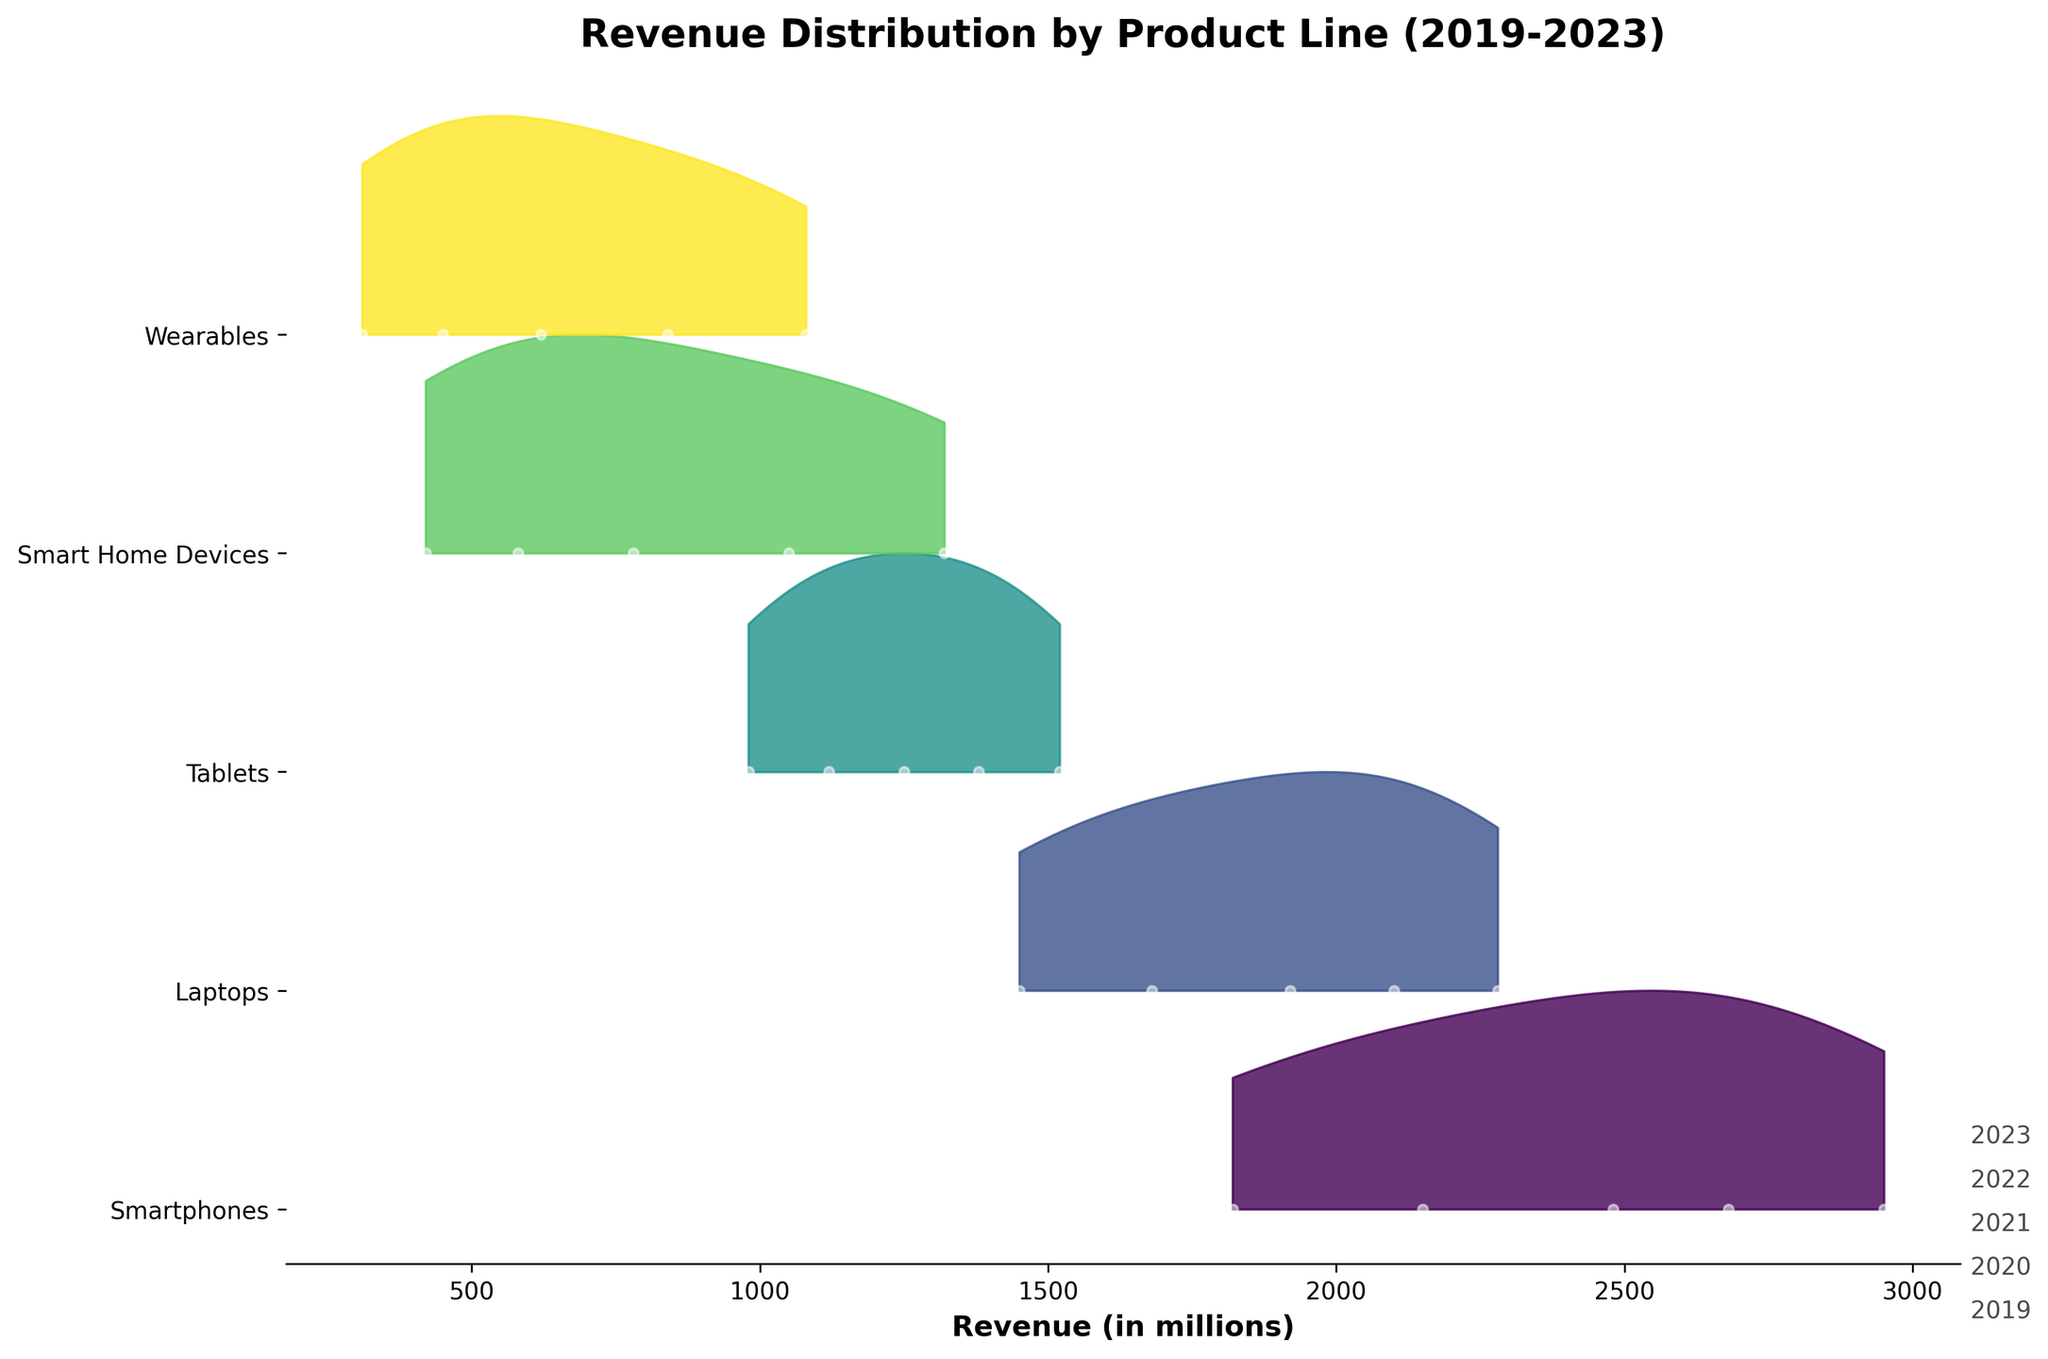How many product lines are displayed in the plot? Count the number of distinct y-tick labels representing the different product lines in the figure.
Answer: Five What is the title of the plot? Look at the text displayed at the top of the figure, which represents the title.
Answer: Revenue Distribution by Product Line (2019-2023) Which product line shows the highest revenue in 2023? Check the highest point for the year 2023 on the x-axis and see which product line it aligns with on the y-axis.
Answer: Smartphones How does the revenue of Wearables in 2021 compare to that of Tablets in 2021? Locate the points for Wearables and Tablets in 2021 and compare their positions on the x-axis to determine which is higher.
Answer: Wearables is higher What is the revenue distribution range for Smart Home Devices? Identify the minimum and maximum points of the distribution for Smart Home Devices on the x-axis.
Answer: 420 to 1320 What trend can you observe in the revenue of Laptops from 2019 to 2023? Track the points for Laptops across all years and observe whether the values generally increase, decrease, or stay constant.
Answer: Increasing What is the median revenue for Tablets over the past 5 years? Order the revenue values for Tablets and find the middle value: (980, 1120, 1250, 1380, 1520) -> median is 1250.
Answer: 1250 Considering the figures for 2023, which product line has shown the largest percentage growth since 2019? Calculate the percentage change for each product line from 2019 to 2023, then determine which is the highest: \[(Smart Home Devices: (1320-420)/420 * 100% = 214.29%)\].
Answer: Smart Home Devices Which product shows the least variability in revenue distribution over the years? Compare the spread of the distributions (width of the filled areas) for all products.
Answer: Tablets Is there a product line that shows growth every year without any decline in revenue? Check each product's revenue across all years to see if there is any year with a lower revenue compared to the previous year.
Answer: Yes, Smartphones 